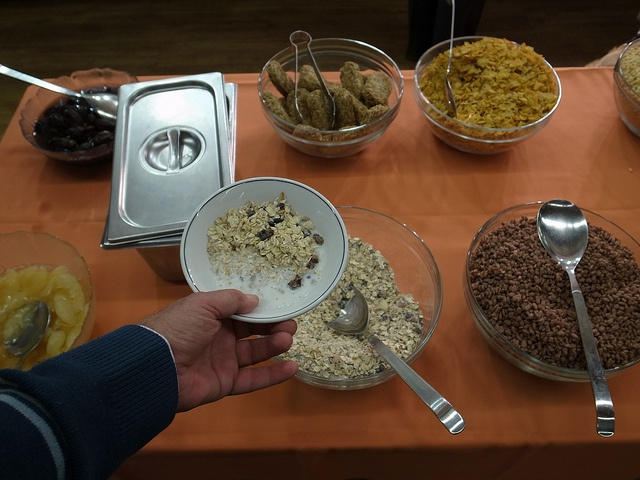Describe the objects in this image and their specific colors. I can see dining table in black, maroon, and brown tones, people in black, maroon, and brown tones, bowl in black, maroon, and gray tones, bowl in black and gray tones, and bowl in black, darkgray, and gray tones in this image. 